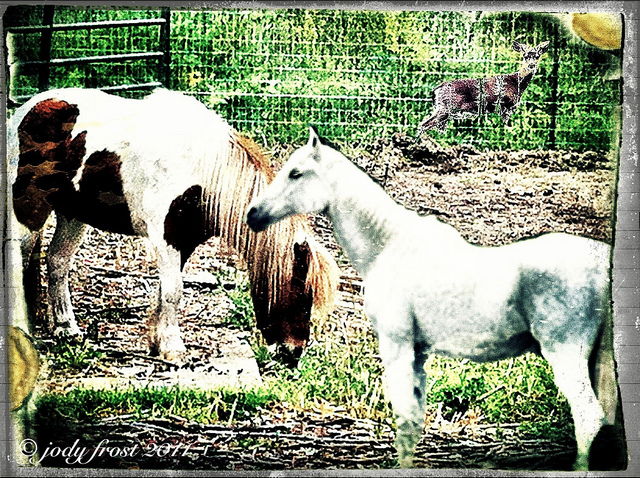Please extract the text content from this image. 2011 frost jody 